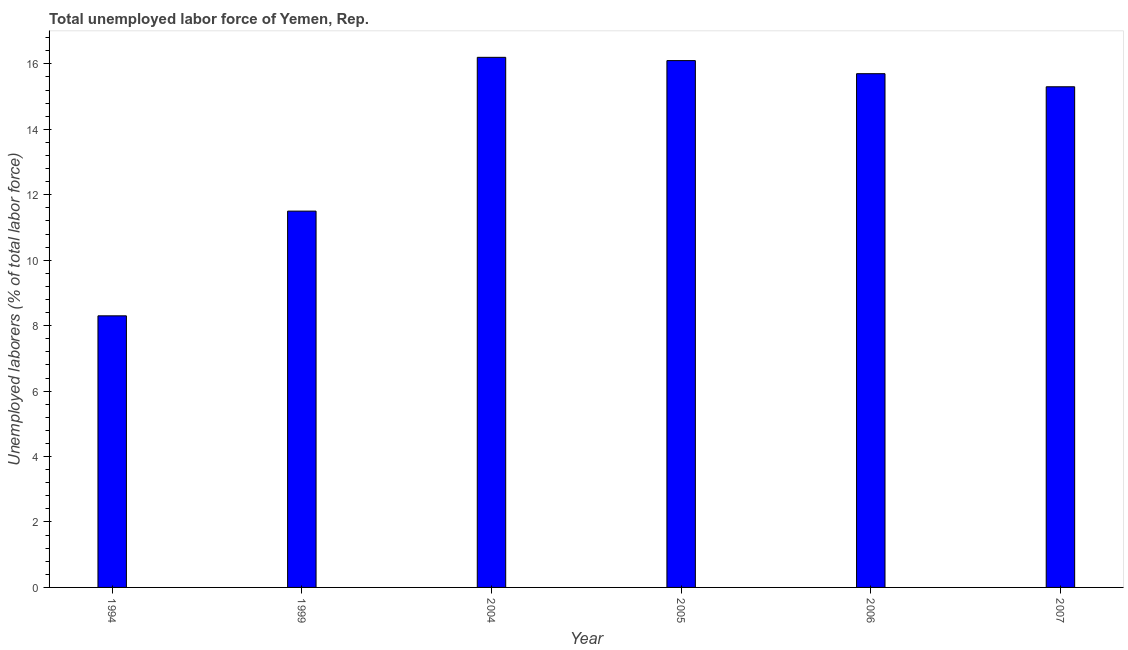Does the graph contain any zero values?
Your response must be concise. No. What is the title of the graph?
Your answer should be very brief. Total unemployed labor force of Yemen, Rep. What is the label or title of the Y-axis?
Ensure brevity in your answer.  Unemployed laborers (% of total labor force). What is the total unemployed labour force in 2004?
Give a very brief answer. 16.2. Across all years, what is the maximum total unemployed labour force?
Offer a very short reply. 16.2. Across all years, what is the minimum total unemployed labour force?
Offer a terse response. 8.3. In which year was the total unemployed labour force maximum?
Provide a short and direct response. 2004. In which year was the total unemployed labour force minimum?
Offer a terse response. 1994. What is the sum of the total unemployed labour force?
Keep it short and to the point. 83.1. What is the average total unemployed labour force per year?
Provide a short and direct response. 13.85. What is the median total unemployed labour force?
Offer a terse response. 15.5. Do a majority of the years between 2006 and 1994 (inclusive) have total unemployed labour force greater than 13.6 %?
Make the answer very short. Yes. What is the ratio of the total unemployed labour force in 1994 to that in 2007?
Offer a very short reply. 0.54. Is the total unemployed labour force in 1999 less than that in 2004?
Give a very brief answer. Yes. Is the sum of the total unemployed labour force in 1994 and 2004 greater than the maximum total unemployed labour force across all years?
Provide a succinct answer. Yes. What is the difference between the highest and the lowest total unemployed labour force?
Make the answer very short. 7.9. In how many years, is the total unemployed labour force greater than the average total unemployed labour force taken over all years?
Offer a very short reply. 4. How many bars are there?
Your response must be concise. 6. How many years are there in the graph?
Make the answer very short. 6. What is the difference between two consecutive major ticks on the Y-axis?
Offer a very short reply. 2. Are the values on the major ticks of Y-axis written in scientific E-notation?
Ensure brevity in your answer.  No. What is the Unemployed laborers (% of total labor force) in 1994?
Keep it short and to the point. 8.3. What is the Unemployed laborers (% of total labor force) in 1999?
Ensure brevity in your answer.  11.5. What is the Unemployed laborers (% of total labor force) in 2004?
Provide a short and direct response. 16.2. What is the Unemployed laborers (% of total labor force) of 2005?
Provide a short and direct response. 16.1. What is the Unemployed laborers (% of total labor force) of 2006?
Your answer should be compact. 15.7. What is the Unemployed laborers (% of total labor force) in 2007?
Ensure brevity in your answer.  15.3. What is the difference between the Unemployed laborers (% of total labor force) in 1994 and 1999?
Offer a very short reply. -3.2. What is the difference between the Unemployed laborers (% of total labor force) in 1994 and 2005?
Give a very brief answer. -7.8. What is the difference between the Unemployed laborers (% of total labor force) in 1994 and 2006?
Offer a very short reply. -7.4. What is the difference between the Unemployed laborers (% of total labor force) in 1999 and 2004?
Provide a short and direct response. -4.7. What is the difference between the Unemployed laborers (% of total labor force) in 1999 and 2005?
Provide a short and direct response. -4.6. What is the difference between the Unemployed laborers (% of total labor force) in 1999 and 2006?
Keep it short and to the point. -4.2. What is the difference between the Unemployed laborers (% of total labor force) in 2004 and 2007?
Your response must be concise. 0.9. What is the difference between the Unemployed laborers (% of total labor force) in 2005 and 2007?
Keep it short and to the point. 0.8. What is the difference between the Unemployed laborers (% of total labor force) in 2006 and 2007?
Your response must be concise. 0.4. What is the ratio of the Unemployed laborers (% of total labor force) in 1994 to that in 1999?
Provide a succinct answer. 0.72. What is the ratio of the Unemployed laborers (% of total labor force) in 1994 to that in 2004?
Make the answer very short. 0.51. What is the ratio of the Unemployed laborers (% of total labor force) in 1994 to that in 2005?
Give a very brief answer. 0.52. What is the ratio of the Unemployed laborers (% of total labor force) in 1994 to that in 2006?
Offer a terse response. 0.53. What is the ratio of the Unemployed laborers (% of total labor force) in 1994 to that in 2007?
Make the answer very short. 0.54. What is the ratio of the Unemployed laborers (% of total labor force) in 1999 to that in 2004?
Ensure brevity in your answer.  0.71. What is the ratio of the Unemployed laborers (% of total labor force) in 1999 to that in 2005?
Offer a terse response. 0.71. What is the ratio of the Unemployed laborers (% of total labor force) in 1999 to that in 2006?
Provide a short and direct response. 0.73. What is the ratio of the Unemployed laborers (% of total labor force) in 1999 to that in 2007?
Your answer should be compact. 0.75. What is the ratio of the Unemployed laborers (% of total labor force) in 2004 to that in 2005?
Offer a very short reply. 1.01. What is the ratio of the Unemployed laborers (% of total labor force) in 2004 to that in 2006?
Give a very brief answer. 1.03. What is the ratio of the Unemployed laborers (% of total labor force) in 2004 to that in 2007?
Give a very brief answer. 1.06. What is the ratio of the Unemployed laborers (% of total labor force) in 2005 to that in 2007?
Keep it short and to the point. 1.05. What is the ratio of the Unemployed laborers (% of total labor force) in 2006 to that in 2007?
Provide a short and direct response. 1.03. 